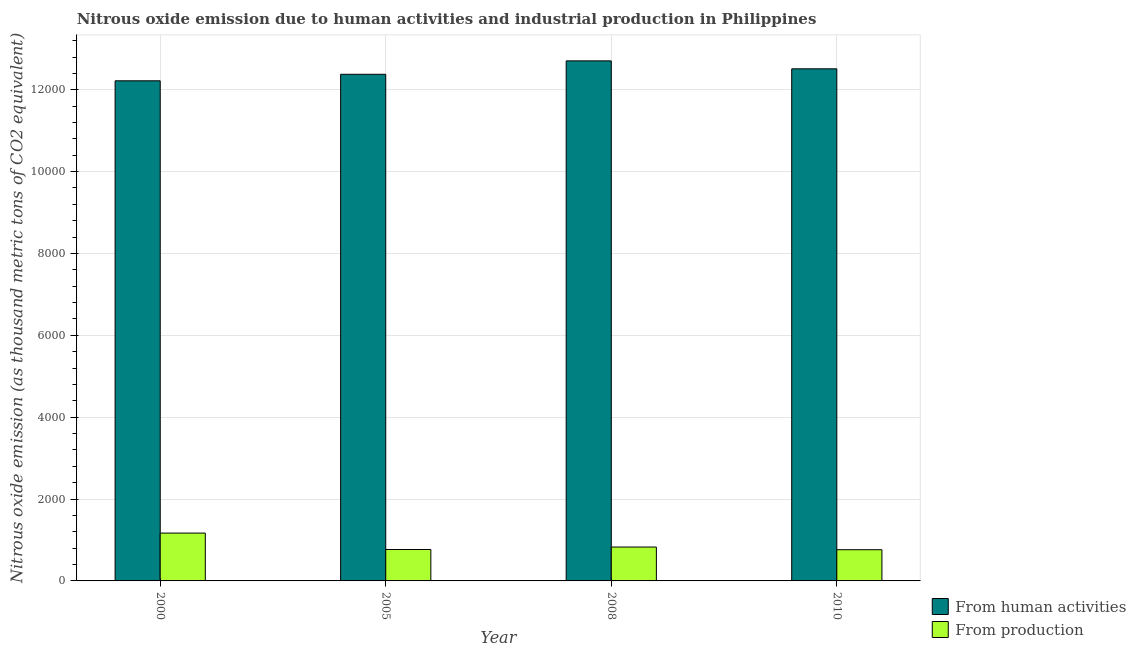How many different coloured bars are there?
Offer a terse response. 2. How many groups of bars are there?
Provide a succinct answer. 4. How many bars are there on the 1st tick from the left?
Your answer should be compact. 2. How many bars are there on the 3rd tick from the right?
Your answer should be compact. 2. What is the amount of emissions generated from industries in 2005?
Your response must be concise. 767.6. Across all years, what is the maximum amount of emissions from human activities?
Keep it short and to the point. 1.27e+04. Across all years, what is the minimum amount of emissions generated from industries?
Provide a succinct answer. 762.1. In which year was the amount of emissions generated from industries minimum?
Give a very brief answer. 2010. What is the total amount of emissions generated from industries in the graph?
Ensure brevity in your answer.  3526.4. What is the difference between the amount of emissions from human activities in 2000 and that in 2005?
Keep it short and to the point. -159. What is the difference between the amount of emissions generated from industries in 2000 and the amount of emissions from human activities in 2010?
Provide a succinct answer. 406.6. What is the average amount of emissions generated from industries per year?
Your response must be concise. 881.6. In the year 2008, what is the difference between the amount of emissions generated from industries and amount of emissions from human activities?
Offer a very short reply. 0. In how many years, is the amount of emissions from human activities greater than 8000 thousand metric tons?
Provide a succinct answer. 4. What is the ratio of the amount of emissions from human activities in 2000 to that in 2008?
Provide a succinct answer. 0.96. What is the difference between the highest and the second highest amount of emissions from human activities?
Provide a succinct answer. 194.2. What is the difference between the highest and the lowest amount of emissions generated from industries?
Your answer should be compact. 406.6. Is the sum of the amount of emissions generated from industries in 2000 and 2010 greater than the maximum amount of emissions from human activities across all years?
Ensure brevity in your answer.  Yes. What does the 2nd bar from the left in 2008 represents?
Offer a very short reply. From production. What does the 1st bar from the right in 2008 represents?
Your answer should be very brief. From production. Are all the bars in the graph horizontal?
Offer a terse response. No. How many years are there in the graph?
Offer a very short reply. 4. What is the difference between two consecutive major ticks on the Y-axis?
Make the answer very short. 2000. Are the values on the major ticks of Y-axis written in scientific E-notation?
Give a very brief answer. No. What is the title of the graph?
Provide a succinct answer. Nitrous oxide emission due to human activities and industrial production in Philippines. What is the label or title of the Y-axis?
Provide a short and direct response. Nitrous oxide emission (as thousand metric tons of CO2 equivalent). What is the Nitrous oxide emission (as thousand metric tons of CO2 equivalent) in From human activities in 2000?
Provide a short and direct response. 1.22e+04. What is the Nitrous oxide emission (as thousand metric tons of CO2 equivalent) of From production in 2000?
Keep it short and to the point. 1168.7. What is the Nitrous oxide emission (as thousand metric tons of CO2 equivalent) of From human activities in 2005?
Ensure brevity in your answer.  1.24e+04. What is the Nitrous oxide emission (as thousand metric tons of CO2 equivalent) in From production in 2005?
Make the answer very short. 767.6. What is the Nitrous oxide emission (as thousand metric tons of CO2 equivalent) in From human activities in 2008?
Give a very brief answer. 1.27e+04. What is the Nitrous oxide emission (as thousand metric tons of CO2 equivalent) of From production in 2008?
Offer a terse response. 828. What is the Nitrous oxide emission (as thousand metric tons of CO2 equivalent) in From human activities in 2010?
Make the answer very short. 1.25e+04. What is the Nitrous oxide emission (as thousand metric tons of CO2 equivalent) of From production in 2010?
Give a very brief answer. 762.1. Across all years, what is the maximum Nitrous oxide emission (as thousand metric tons of CO2 equivalent) of From human activities?
Offer a terse response. 1.27e+04. Across all years, what is the maximum Nitrous oxide emission (as thousand metric tons of CO2 equivalent) in From production?
Make the answer very short. 1168.7. Across all years, what is the minimum Nitrous oxide emission (as thousand metric tons of CO2 equivalent) in From human activities?
Your response must be concise. 1.22e+04. Across all years, what is the minimum Nitrous oxide emission (as thousand metric tons of CO2 equivalent) of From production?
Provide a short and direct response. 762.1. What is the total Nitrous oxide emission (as thousand metric tons of CO2 equivalent) in From human activities in the graph?
Offer a terse response. 4.98e+04. What is the total Nitrous oxide emission (as thousand metric tons of CO2 equivalent) of From production in the graph?
Offer a very short reply. 3526.4. What is the difference between the Nitrous oxide emission (as thousand metric tons of CO2 equivalent) in From human activities in 2000 and that in 2005?
Ensure brevity in your answer.  -159. What is the difference between the Nitrous oxide emission (as thousand metric tons of CO2 equivalent) of From production in 2000 and that in 2005?
Your answer should be very brief. 401.1. What is the difference between the Nitrous oxide emission (as thousand metric tons of CO2 equivalent) of From human activities in 2000 and that in 2008?
Offer a very short reply. -486.8. What is the difference between the Nitrous oxide emission (as thousand metric tons of CO2 equivalent) in From production in 2000 and that in 2008?
Keep it short and to the point. 340.7. What is the difference between the Nitrous oxide emission (as thousand metric tons of CO2 equivalent) in From human activities in 2000 and that in 2010?
Ensure brevity in your answer.  -292.6. What is the difference between the Nitrous oxide emission (as thousand metric tons of CO2 equivalent) of From production in 2000 and that in 2010?
Make the answer very short. 406.6. What is the difference between the Nitrous oxide emission (as thousand metric tons of CO2 equivalent) in From human activities in 2005 and that in 2008?
Keep it short and to the point. -327.8. What is the difference between the Nitrous oxide emission (as thousand metric tons of CO2 equivalent) in From production in 2005 and that in 2008?
Your response must be concise. -60.4. What is the difference between the Nitrous oxide emission (as thousand metric tons of CO2 equivalent) of From human activities in 2005 and that in 2010?
Your answer should be very brief. -133.6. What is the difference between the Nitrous oxide emission (as thousand metric tons of CO2 equivalent) in From production in 2005 and that in 2010?
Your answer should be compact. 5.5. What is the difference between the Nitrous oxide emission (as thousand metric tons of CO2 equivalent) in From human activities in 2008 and that in 2010?
Offer a terse response. 194.2. What is the difference between the Nitrous oxide emission (as thousand metric tons of CO2 equivalent) of From production in 2008 and that in 2010?
Provide a succinct answer. 65.9. What is the difference between the Nitrous oxide emission (as thousand metric tons of CO2 equivalent) in From human activities in 2000 and the Nitrous oxide emission (as thousand metric tons of CO2 equivalent) in From production in 2005?
Make the answer very short. 1.15e+04. What is the difference between the Nitrous oxide emission (as thousand metric tons of CO2 equivalent) of From human activities in 2000 and the Nitrous oxide emission (as thousand metric tons of CO2 equivalent) of From production in 2008?
Provide a succinct answer. 1.14e+04. What is the difference between the Nitrous oxide emission (as thousand metric tons of CO2 equivalent) in From human activities in 2000 and the Nitrous oxide emission (as thousand metric tons of CO2 equivalent) in From production in 2010?
Your answer should be very brief. 1.15e+04. What is the difference between the Nitrous oxide emission (as thousand metric tons of CO2 equivalent) in From human activities in 2005 and the Nitrous oxide emission (as thousand metric tons of CO2 equivalent) in From production in 2008?
Offer a terse response. 1.16e+04. What is the difference between the Nitrous oxide emission (as thousand metric tons of CO2 equivalent) in From human activities in 2005 and the Nitrous oxide emission (as thousand metric tons of CO2 equivalent) in From production in 2010?
Provide a short and direct response. 1.16e+04. What is the difference between the Nitrous oxide emission (as thousand metric tons of CO2 equivalent) of From human activities in 2008 and the Nitrous oxide emission (as thousand metric tons of CO2 equivalent) of From production in 2010?
Provide a succinct answer. 1.19e+04. What is the average Nitrous oxide emission (as thousand metric tons of CO2 equivalent) in From human activities per year?
Your response must be concise. 1.25e+04. What is the average Nitrous oxide emission (as thousand metric tons of CO2 equivalent) of From production per year?
Offer a terse response. 881.6. In the year 2000, what is the difference between the Nitrous oxide emission (as thousand metric tons of CO2 equivalent) in From human activities and Nitrous oxide emission (as thousand metric tons of CO2 equivalent) in From production?
Offer a very short reply. 1.11e+04. In the year 2005, what is the difference between the Nitrous oxide emission (as thousand metric tons of CO2 equivalent) of From human activities and Nitrous oxide emission (as thousand metric tons of CO2 equivalent) of From production?
Provide a short and direct response. 1.16e+04. In the year 2008, what is the difference between the Nitrous oxide emission (as thousand metric tons of CO2 equivalent) in From human activities and Nitrous oxide emission (as thousand metric tons of CO2 equivalent) in From production?
Keep it short and to the point. 1.19e+04. In the year 2010, what is the difference between the Nitrous oxide emission (as thousand metric tons of CO2 equivalent) of From human activities and Nitrous oxide emission (as thousand metric tons of CO2 equivalent) of From production?
Offer a terse response. 1.17e+04. What is the ratio of the Nitrous oxide emission (as thousand metric tons of CO2 equivalent) of From human activities in 2000 to that in 2005?
Your answer should be compact. 0.99. What is the ratio of the Nitrous oxide emission (as thousand metric tons of CO2 equivalent) in From production in 2000 to that in 2005?
Your answer should be compact. 1.52. What is the ratio of the Nitrous oxide emission (as thousand metric tons of CO2 equivalent) in From human activities in 2000 to that in 2008?
Offer a terse response. 0.96. What is the ratio of the Nitrous oxide emission (as thousand metric tons of CO2 equivalent) in From production in 2000 to that in 2008?
Offer a very short reply. 1.41. What is the ratio of the Nitrous oxide emission (as thousand metric tons of CO2 equivalent) in From human activities in 2000 to that in 2010?
Provide a short and direct response. 0.98. What is the ratio of the Nitrous oxide emission (as thousand metric tons of CO2 equivalent) of From production in 2000 to that in 2010?
Your answer should be very brief. 1.53. What is the ratio of the Nitrous oxide emission (as thousand metric tons of CO2 equivalent) in From human activities in 2005 to that in 2008?
Provide a short and direct response. 0.97. What is the ratio of the Nitrous oxide emission (as thousand metric tons of CO2 equivalent) in From production in 2005 to that in 2008?
Keep it short and to the point. 0.93. What is the ratio of the Nitrous oxide emission (as thousand metric tons of CO2 equivalent) in From human activities in 2005 to that in 2010?
Provide a short and direct response. 0.99. What is the ratio of the Nitrous oxide emission (as thousand metric tons of CO2 equivalent) of From human activities in 2008 to that in 2010?
Give a very brief answer. 1.02. What is the ratio of the Nitrous oxide emission (as thousand metric tons of CO2 equivalent) of From production in 2008 to that in 2010?
Ensure brevity in your answer.  1.09. What is the difference between the highest and the second highest Nitrous oxide emission (as thousand metric tons of CO2 equivalent) of From human activities?
Your answer should be compact. 194.2. What is the difference between the highest and the second highest Nitrous oxide emission (as thousand metric tons of CO2 equivalent) in From production?
Make the answer very short. 340.7. What is the difference between the highest and the lowest Nitrous oxide emission (as thousand metric tons of CO2 equivalent) in From human activities?
Keep it short and to the point. 486.8. What is the difference between the highest and the lowest Nitrous oxide emission (as thousand metric tons of CO2 equivalent) of From production?
Your response must be concise. 406.6. 